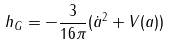Convert formula to latex. <formula><loc_0><loc_0><loc_500><loc_500>h _ { G } = - \frac { 3 } { 1 6 \pi } ( \dot { a } ^ { 2 } + V ( a ) )</formula> 